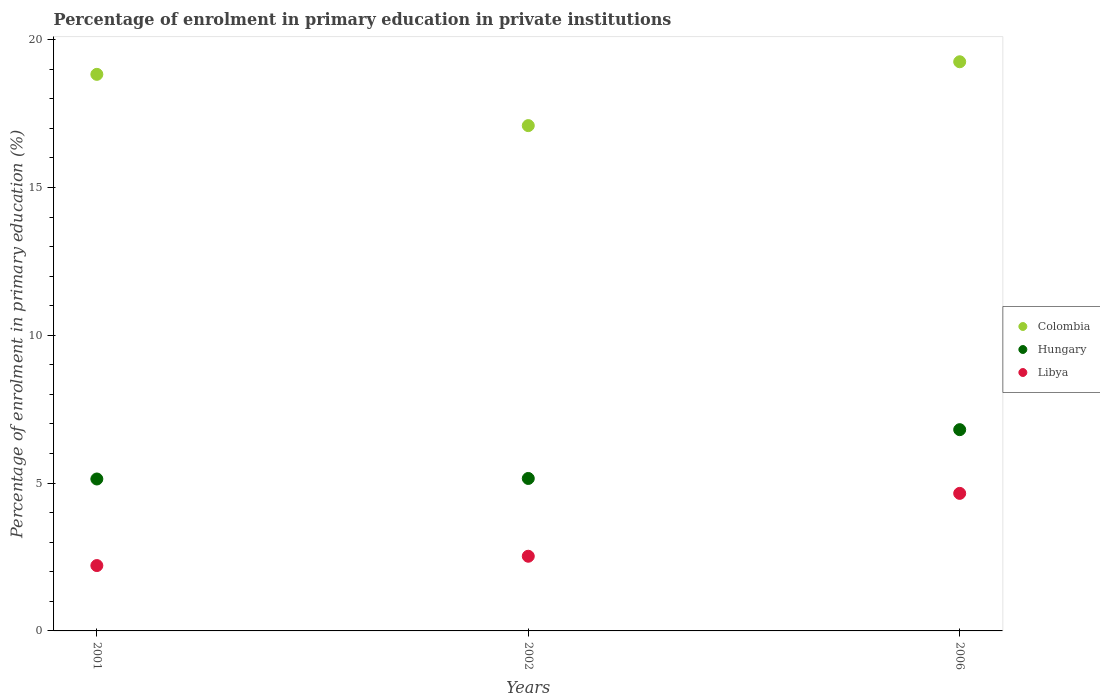How many different coloured dotlines are there?
Your answer should be compact. 3. Is the number of dotlines equal to the number of legend labels?
Offer a terse response. Yes. What is the percentage of enrolment in primary education in Libya in 2006?
Make the answer very short. 4.65. Across all years, what is the maximum percentage of enrolment in primary education in Colombia?
Make the answer very short. 19.25. Across all years, what is the minimum percentage of enrolment in primary education in Hungary?
Provide a short and direct response. 5.14. In which year was the percentage of enrolment in primary education in Colombia minimum?
Your response must be concise. 2002. What is the total percentage of enrolment in primary education in Hungary in the graph?
Your answer should be compact. 17.1. What is the difference between the percentage of enrolment in primary education in Hungary in 2001 and that in 2006?
Give a very brief answer. -1.67. What is the difference between the percentage of enrolment in primary education in Hungary in 2002 and the percentage of enrolment in primary education in Colombia in 2001?
Provide a succinct answer. -13.67. What is the average percentage of enrolment in primary education in Libya per year?
Ensure brevity in your answer.  3.13. In the year 2002, what is the difference between the percentage of enrolment in primary education in Libya and percentage of enrolment in primary education in Hungary?
Give a very brief answer. -2.63. In how many years, is the percentage of enrolment in primary education in Hungary greater than 16 %?
Offer a terse response. 0. What is the ratio of the percentage of enrolment in primary education in Hungary in 2001 to that in 2002?
Provide a short and direct response. 1. Is the percentage of enrolment in primary education in Colombia in 2001 less than that in 2002?
Ensure brevity in your answer.  No. Is the difference between the percentage of enrolment in primary education in Libya in 2002 and 2006 greater than the difference between the percentage of enrolment in primary education in Hungary in 2002 and 2006?
Your response must be concise. No. What is the difference between the highest and the second highest percentage of enrolment in primary education in Colombia?
Provide a succinct answer. 0.43. What is the difference between the highest and the lowest percentage of enrolment in primary education in Hungary?
Keep it short and to the point. 1.67. Is it the case that in every year, the sum of the percentage of enrolment in primary education in Libya and percentage of enrolment in primary education in Colombia  is greater than the percentage of enrolment in primary education in Hungary?
Offer a very short reply. Yes. What is the difference between two consecutive major ticks on the Y-axis?
Your answer should be compact. 5. Does the graph contain any zero values?
Your answer should be compact. No. Where does the legend appear in the graph?
Make the answer very short. Center right. What is the title of the graph?
Your response must be concise. Percentage of enrolment in primary education in private institutions. What is the label or title of the Y-axis?
Make the answer very short. Percentage of enrolment in primary education (%). What is the Percentage of enrolment in primary education (%) of Colombia in 2001?
Offer a very short reply. 18.83. What is the Percentage of enrolment in primary education (%) in Hungary in 2001?
Provide a succinct answer. 5.14. What is the Percentage of enrolment in primary education (%) of Libya in 2001?
Your answer should be compact. 2.21. What is the Percentage of enrolment in primary education (%) in Colombia in 2002?
Your response must be concise. 17.09. What is the Percentage of enrolment in primary education (%) of Hungary in 2002?
Give a very brief answer. 5.16. What is the Percentage of enrolment in primary education (%) of Libya in 2002?
Your answer should be very brief. 2.53. What is the Percentage of enrolment in primary education (%) in Colombia in 2006?
Keep it short and to the point. 19.25. What is the Percentage of enrolment in primary education (%) of Hungary in 2006?
Give a very brief answer. 6.81. What is the Percentage of enrolment in primary education (%) of Libya in 2006?
Keep it short and to the point. 4.65. Across all years, what is the maximum Percentage of enrolment in primary education (%) of Colombia?
Your answer should be compact. 19.25. Across all years, what is the maximum Percentage of enrolment in primary education (%) in Hungary?
Keep it short and to the point. 6.81. Across all years, what is the maximum Percentage of enrolment in primary education (%) in Libya?
Give a very brief answer. 4.65. Across all years, what is the minimum Percentage of enrolment in primary education (%) in Colombia?
Provide a short and direct response. 17.09. Across all years, what is the minimum Percentage of enrolment in primary education (%) of Hungary?
Your answer should be very brief. 5.14. Across all years, what is the minimum Percentage of enrolment in primary education (%) in Libya?
Make the answer very short. 2.21. What is the total Percentage of enrolment in primary education (%) of Colombia in the graph?
Keep it short and to the point. 55.17. What is the total Percentage of enrolment in primary education (%) in Hungary in the graph?
Offer a terse response. 17.1. What is the total Percentage of enrolment in primary education (%) in Libya in the graph?
Offer a terse response. 9.39. What is the difference between the Percentage of enrolment in primary education (%) of Colombia in 2001 and that in 2002?
Give a very brief answer. 1.73. What is the difference between the Percentage of enrolment in primary education (%) of Hungary in 2001 and that in 2002?
Offer a terse response. -0.02. What is the difference between the Percentage of enrolment in primary education (%) of Libya in 2001 and that in 2002?
Offer a very short reply. -0.32. What is the difference between the Percentage of enrolment in primary education (%) in Colombia in 2001 and that in 2006?
Provide a short and direct response. -0.43. What is the difference between the Percentage of enrolment in primary education (%) in Hungary in 2001 and that in 2006?
Provide a succinct answer. -1.67. What is the difference between the Percentage of enrolment in primary education (%) in Libya in 2001 and that in 2006?
Keep it short and to the point. -2.44. What is the difference between the Percentage of enrolment in primary education (%) of Colombia in 2002 and that in 2006?
Offer a terse response. -2.16. What is the difference between the Percentage of enrolment in primary education (%) in Hungary in 2002 and that in 2006?
Make the answer very short. -1.65. What is the difference between the Percentage of enrolment in primary education (%) in Libya in 2002 and that in 2006?
Offer a terse response. -2.13. What is the difference between the Percentage of enrolment in primary education (%) in Colombia in 2001 and the Percentage of enrolment in primary education (%) in Hungary in 2002?
Provide a short and direct response. 13.67. What is the difference between the Percentage of enrolment in primary education (%) of Colombia in 2001 and the Percentage of enrolment in primary education (%) of Libya in 2002?
Ensure brevity in your answer.  16.3. What is the difference between the Percentage of enrolment in primary education (%) in Hungary in 2001 and the Percentage of enrolment in primary education (%) in Libya in 2002?
Keep it short and to the point. 2.61. What is the difference between the Percentage of enrolment in primary education (%) in Colombia in 2001 and the Percentage of enrolment in primary education (%) in Hungary in 2006?
Ensure brevity in your answer.  12.02. What is the difference between the Percentage of enrolment in primary education (%) in Colombia in 2001 and the Percentage of enrolment in primary education (%) in Libya in 2006?
Make the answer very short. 14.17. What is the difference between the Percentage of enrolment in primary education (%) in Hungary in 2001 and the Percentage of enrolment in primary education (%) in Libya in 2006?
Provide a short and direct response. 0.49. What is the difference between the Percentage of enrolment in primary education (%) of Colombia in 2002 and the Percentage of enrolment in primary education (%) of Hungary in 2006?
Make the answer very short. 10.28. What is the difference between the Percentage of enrolment in primary education (%) in Colombia in 2002 and the Percentage of enrolment in primary education (%) in Libya in 2006?
Provide a succinct answer. 12.44. What is the difference between the Percentage of enrolment in primary education (%) in Hungary in 2002 and the Percentage of enrolment in primary education (%) in Libya in 2006?
Provide a succinct answer. 0.5. What is the average Percentage of enrolment in primary education (%) in Colombia per year?
Offer a very short reply. 18.39. What is the average Percentage of enrolment in primary education (%) of Hungary per year?
Provide a short and direct response. 5.7. What is the average Percentage of enrolment in primary education (%) in Libya per year?
Offer a very short reply. 3.13. In the year 2001, what is the difference between the Percentage of enrolment in primary education (%) of Colombia and Percentage of enrolment in primary education (%) of Hungary?
Give a very brief answer. 13.69. In the year 2001, what is the difference between the Percentage of enrolment in primary education (%) of Colombia and Percentage of enrolment in primary education (%) of Libya?
Provide a short and direct response. 16.61. In the year 2001, what is the difference between the Percentage of enrolment in primary education (%) of Hungary and Percentage of enrolment in primary education (%) of Libya?
Keep it short and to the point. 2.93. In the year 2002, what is the difference between the Percentage of enrolment in primary education (%) of Colombia and Percentage of enrolment in primary education (%) of Hungary?
Your answer should be very brief. 11.93. In the year 2002, what is the difference between the Percentage of enrolment in primary education (%) in Colombia and Percentage of enrolment in primary education (%) in Libya?
Your answer should be compact. 14.57. In the year 2002, what is the difference between the Percentage of enrolment in primary education (%) in Hungary and Percentage of enrolment in primary education (%) in Libya?
Your response must be concise. 2.63. In the year 2006, what is the difference between the Percentage of enrolment in primary education (%) in Colombia and Percentage of enrolment in primary education (%) in Hungary?
Provide a short and direct response. 12.44. In the year 2006, what is the difference between the Percentage of enrolment in primary education (%) in Colombia and Percentage of enrolment in primary education (%) in Libya?
Offer a terse response. 14.6. In the year 2006, what is the difference between the Percentage of enrolment in primary education (%) of Hungary and Percentage of enrolment in primary education (%) of Libya?
Offer a very short reply. 2.15. What is the ratio of the Percentage of enrolment in primary education (%) in Colombia in 2001 to that in 2002?
Offer a terse response. 1.1. What is the ratio of the Percentage of enrolment in primary education (%) in Hungary in 2001 to that in 2002?
Your answer should be compact. 1. What is the ratio of the Percentage of enrolment in primary education (%) in Libya in 2001 to that in 2002?
Provide a succinct answer. 0.88. What is the ratio of the Percentage of enrolment in primary education (%) of Colombia in 2001 to that in 2006?
Make the answer very short. 0.98. What is the ratio of the Percentage of enrolment in primary education (%) of Hungary in 2001 to that in 2006?
Offer a terse response. 0.75. What is the ratio of the Percentage of enrolment in primary education (%) of Libya in 2001 to that in 2006?
Provide a succinct answer. 0.48. What is the ratio of the Percentage of enrolment in primary education (%) of Colombia in 2002 to that in 2006?
Provide a succinct answer. 0.89. What is the ratio of the Percentage of enrolment in primary education (%) of Hungary in 2002 to that in 2006?
Make the answer very short. 0.76. What is the ratio of the Percentage of enrolment in primary education (%) in Libya in 2002 to that in 2006?
Make the answer very short. 0.54. What is the difference between the highest and the second highest Percentage of enrolment in primary education (%) in Colombia?
Your answer should be very brief. 0.43. What is the difference between the highest and the second highest Percentage of enrolment in primary education (%) of Hungary?
Give a very brief answer. 1.65. What is the difference between the highest and the second highest Percentage of enrolment in primary education (%) in Libya?
Provide a short and direct response. 2.13. What is the difference between the highest and the lowest Percentage of enrolment in primary education (%) of Colombia?
Ensure brevity in your answer.  2.16. What is the difference between the highest and the lowest Percentage of enrolment in primary education (%) of Hungary?
Offer a terse response. 1.67. What is the difference between the highest and the lowest Percentage of enrolment in primary education (%) of Libya?
Offer a very short reply. 2.44. 